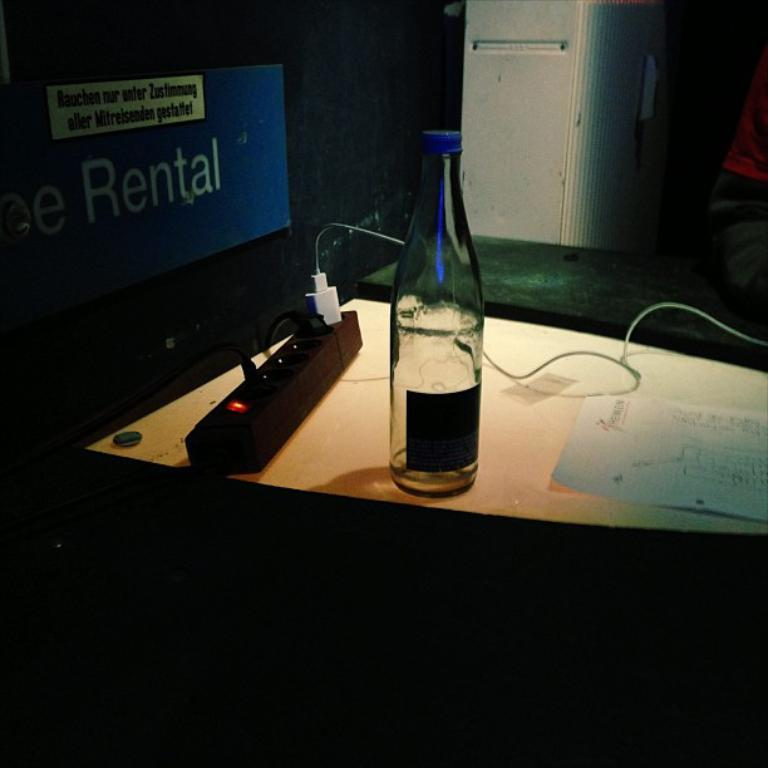<image>
Summarize the visual content of the image. A glass bottle next to a power outlet and a sign saying rental 